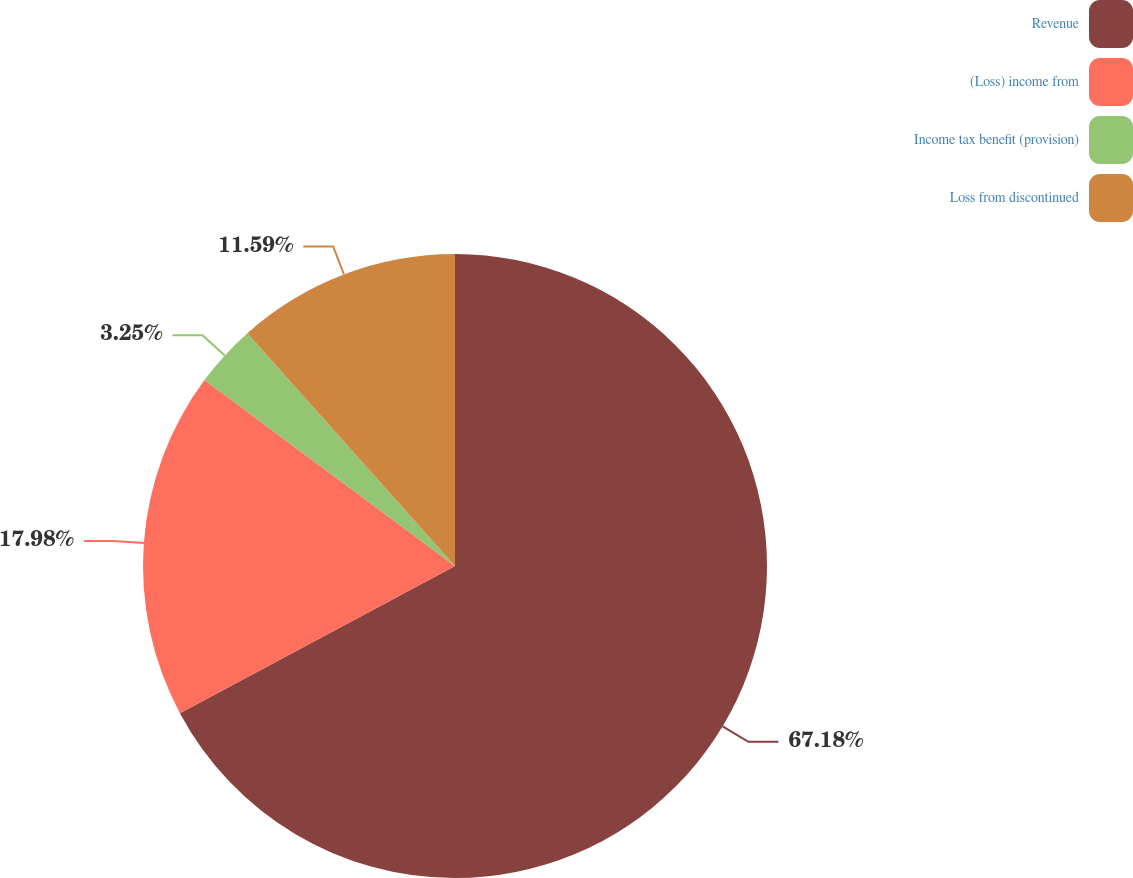Convert chart. <chart><loc_0><loc_0><loc_500><loc_500><pie_chart><fcel>Revenue<fcel>(Loss) income from<fcel>Income tax benefit (provision)<fcel>Loss from discontinued<nl><fcel>67.18%<fcel>17.98%<fcel>3.25%<fcel>11.59%<nl></chart> 